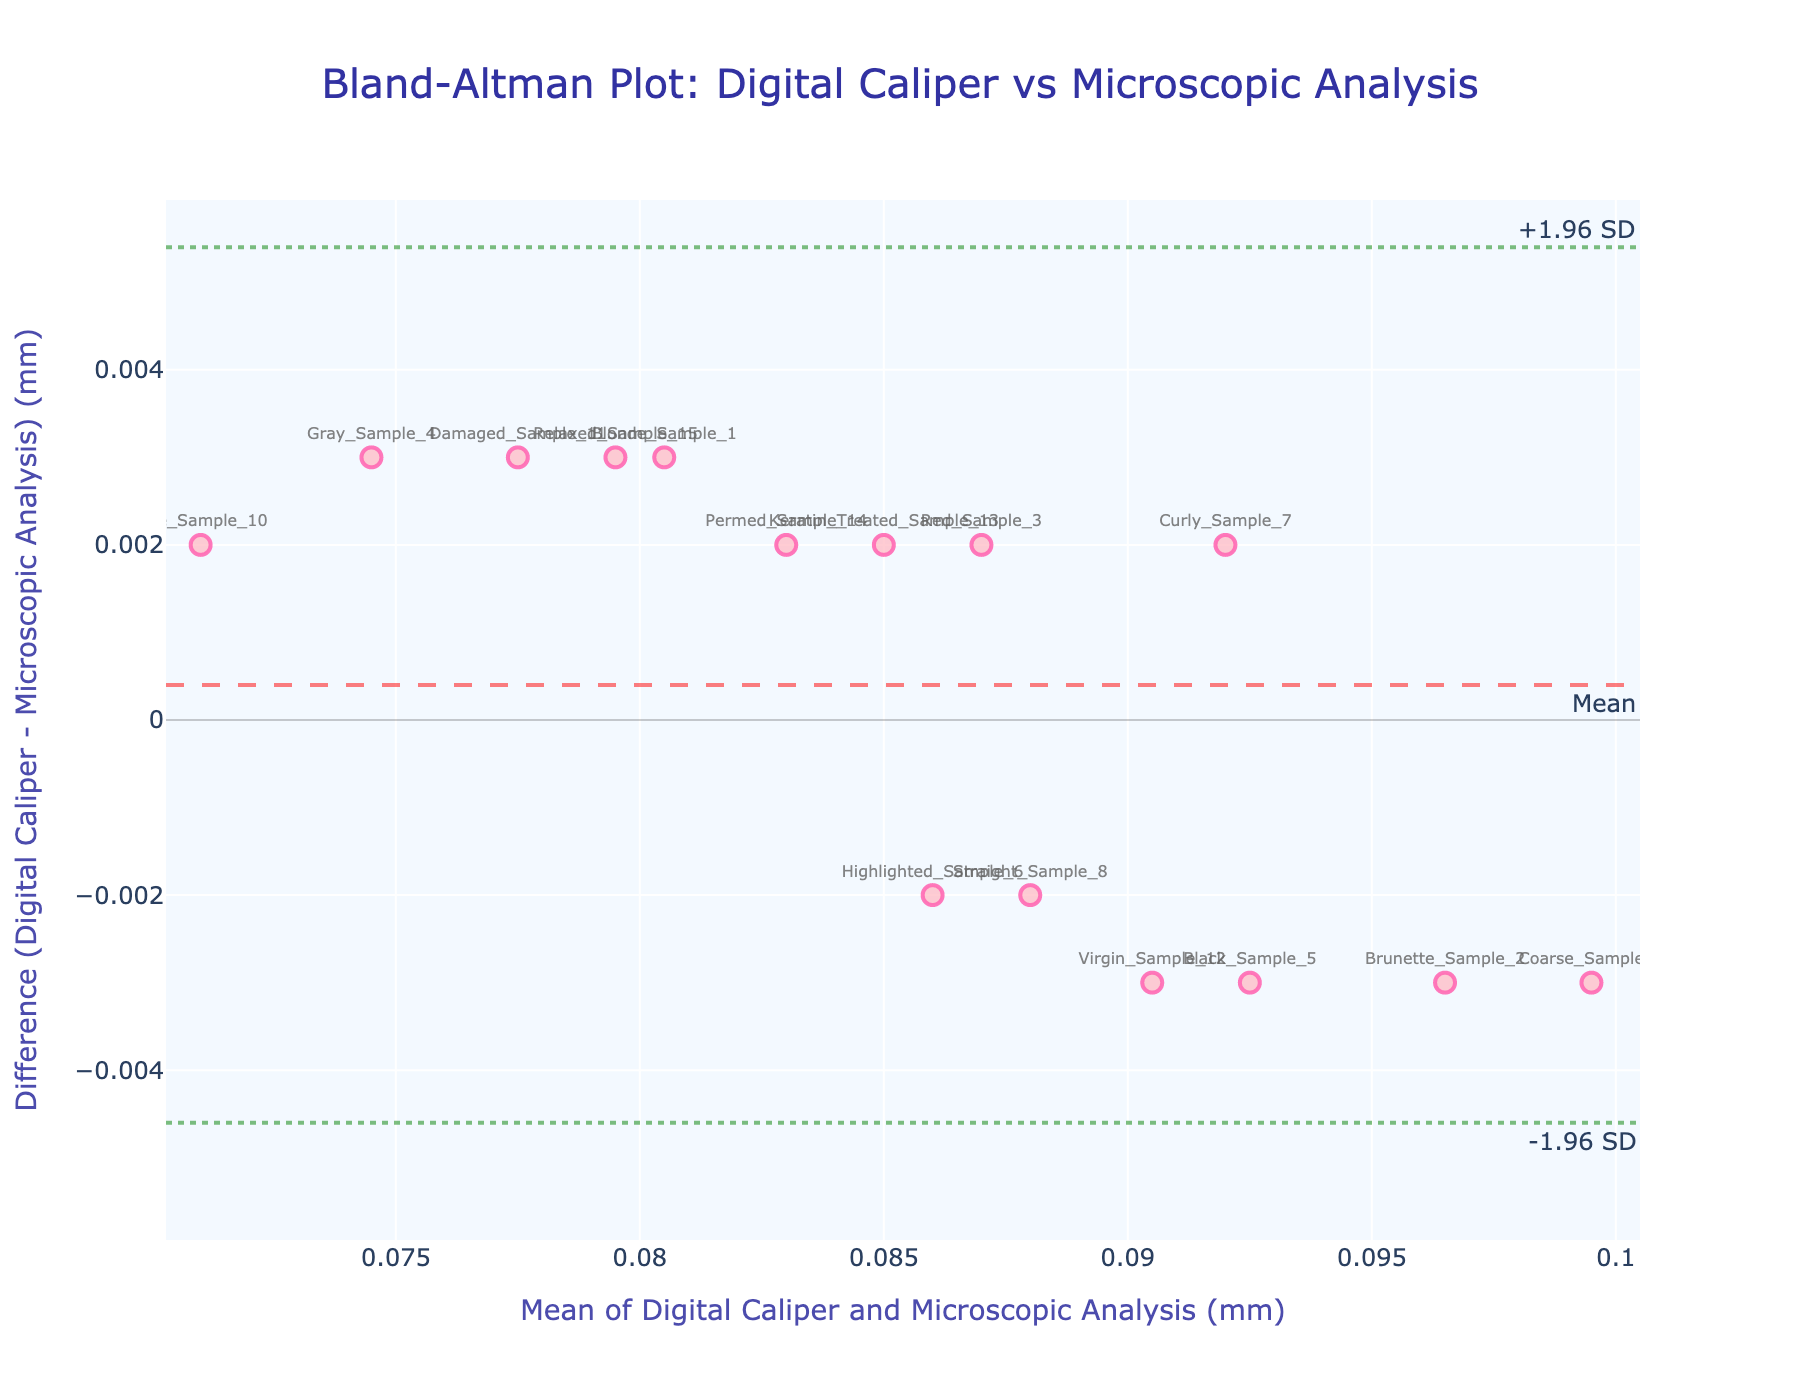What's the title of the plot? The title is the main text displayed at the top of the plot; it indicates the subject of the plot. It helps the observer understand what the figure is about.
Answer: Bland-Altman Plot: Digital Caliper vs Microscopic Analysis What does the x-axis represent? The x-axis typically indicates one of the primary variables in the plot. In this case, it represents the mean of the measurements taken by the Digital Caliper and Microscopic Analysis.
Answer: Mean of Digital Caliper and Microscopic Analysis (mm) What is the mean difference value shown in the plot? The line labeled "Mean" represents the average difference between Digital Caliper and Microscopic Analysis measurements.
Answer: Mean Which sample has the highest mean measurement value? By identifying the data point with the highest x-axis value, we determine the sample with the greatest mean measurement.
Answer: Coarse_Sample_9 What is the difference value for Black_Sample_5? The difference value can be read off the y-axis for the corresponding data point labeled "Black_Sample_5".
Answer: -0.003 Are there any samples whose differences fall outside the limits of agreement? By observing which data points fall beyond the dotted lines representing the limits of agreement (+1.96 SD and -1.96 SD), we determine if any samples are outside these boundaries.
Answer: No Which sample shows the smallest difference between the two measurement methods? The data point closest to the y-axis zero line represents the sample with the smallest difference between the Digital Caliper and Microscopic Analysis measurements.
Answer: Blonde_Sample_1 What are the upper and lower limits of agreement in the figure? These are represented by the dotted lines on the plot, typically calculated as the mean difference ± 1.96 times the standard deviation of the differences.
Answer: Upper: +1.96 SD, Lower: -1.96 SD What's the standard deviation of the differences? The standard deviation can be inferred by knowing the mean difference and the limits of agreement. Using the formula, upper limit = mean diff + 1.96 * std, we can rearrange to solve for std. However, this correctness needs data computation.
Answer: Calculated via data Is there a trend in the differences as the mean measurements increase? Observing the arrangement of data points can indicate a trend. If the differences increase or decrease along with the mean measurements, it signifies a bias or trend.
Answer: Observed visually on plot 